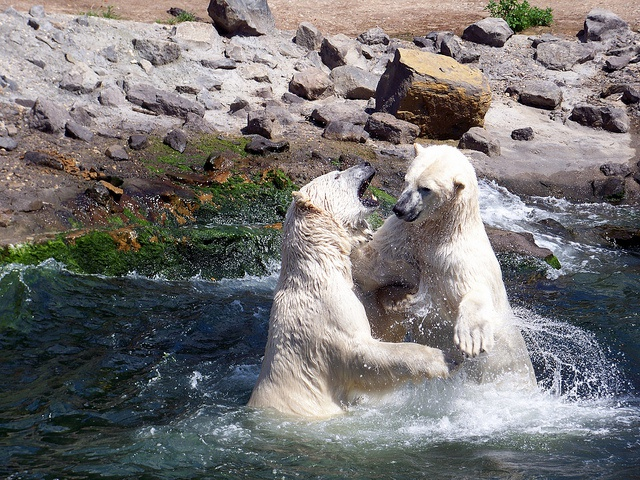Describe the objects in this image and their specific colors. I can see bear in darkgray, lightgray, and gray tones and bear in darkgray, white, gray, and black tones in this image. 